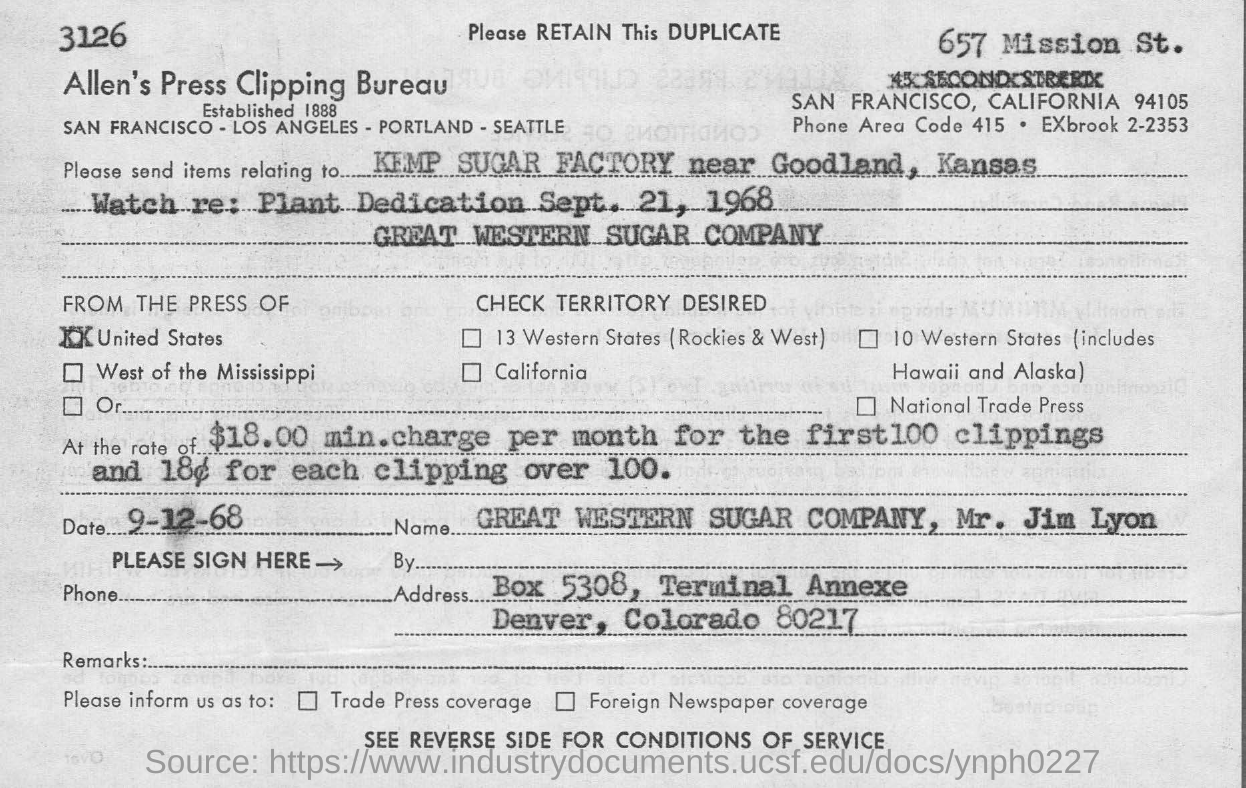Give some essential details in this illustration. The cost per month for the first 100 clippings is $18.00. The zip code for the area of Denver, Colorado is 80217. The phone area code is 415. The KEMP SUGAR FACTORY is the destination where Items are sent. Allen's Press Clipping Bureau is a name of a bureau. 